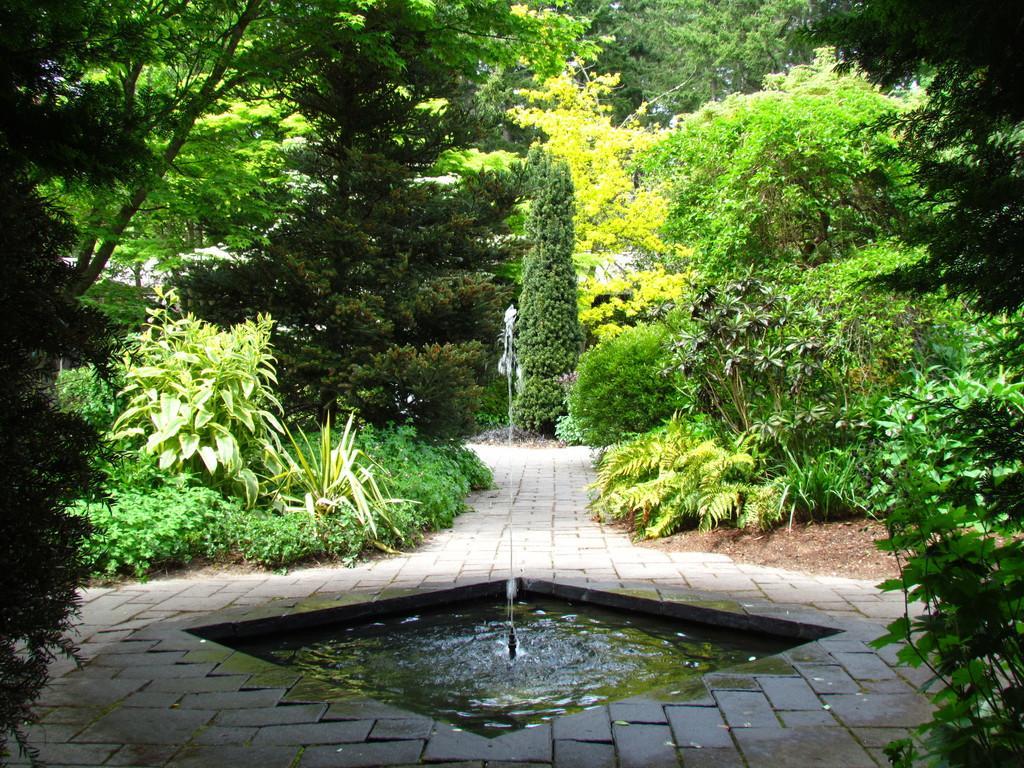Please provide a concise description of this image. In this picture we can see the small water fountain in the center of the image. Behind there are some trees. 